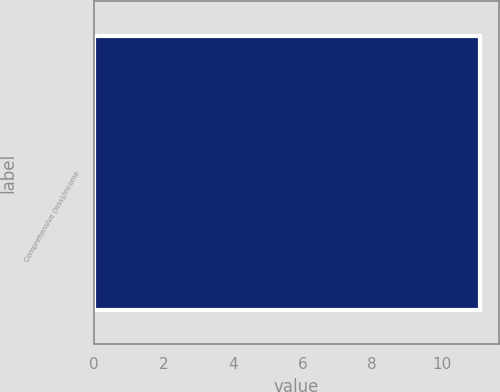<chart> <loc_0><loc_0><loc_500><loc_500><bar_chart><fcel>Comprehensive (loss)/income<nl><fcel>11.1<nl></chart> 